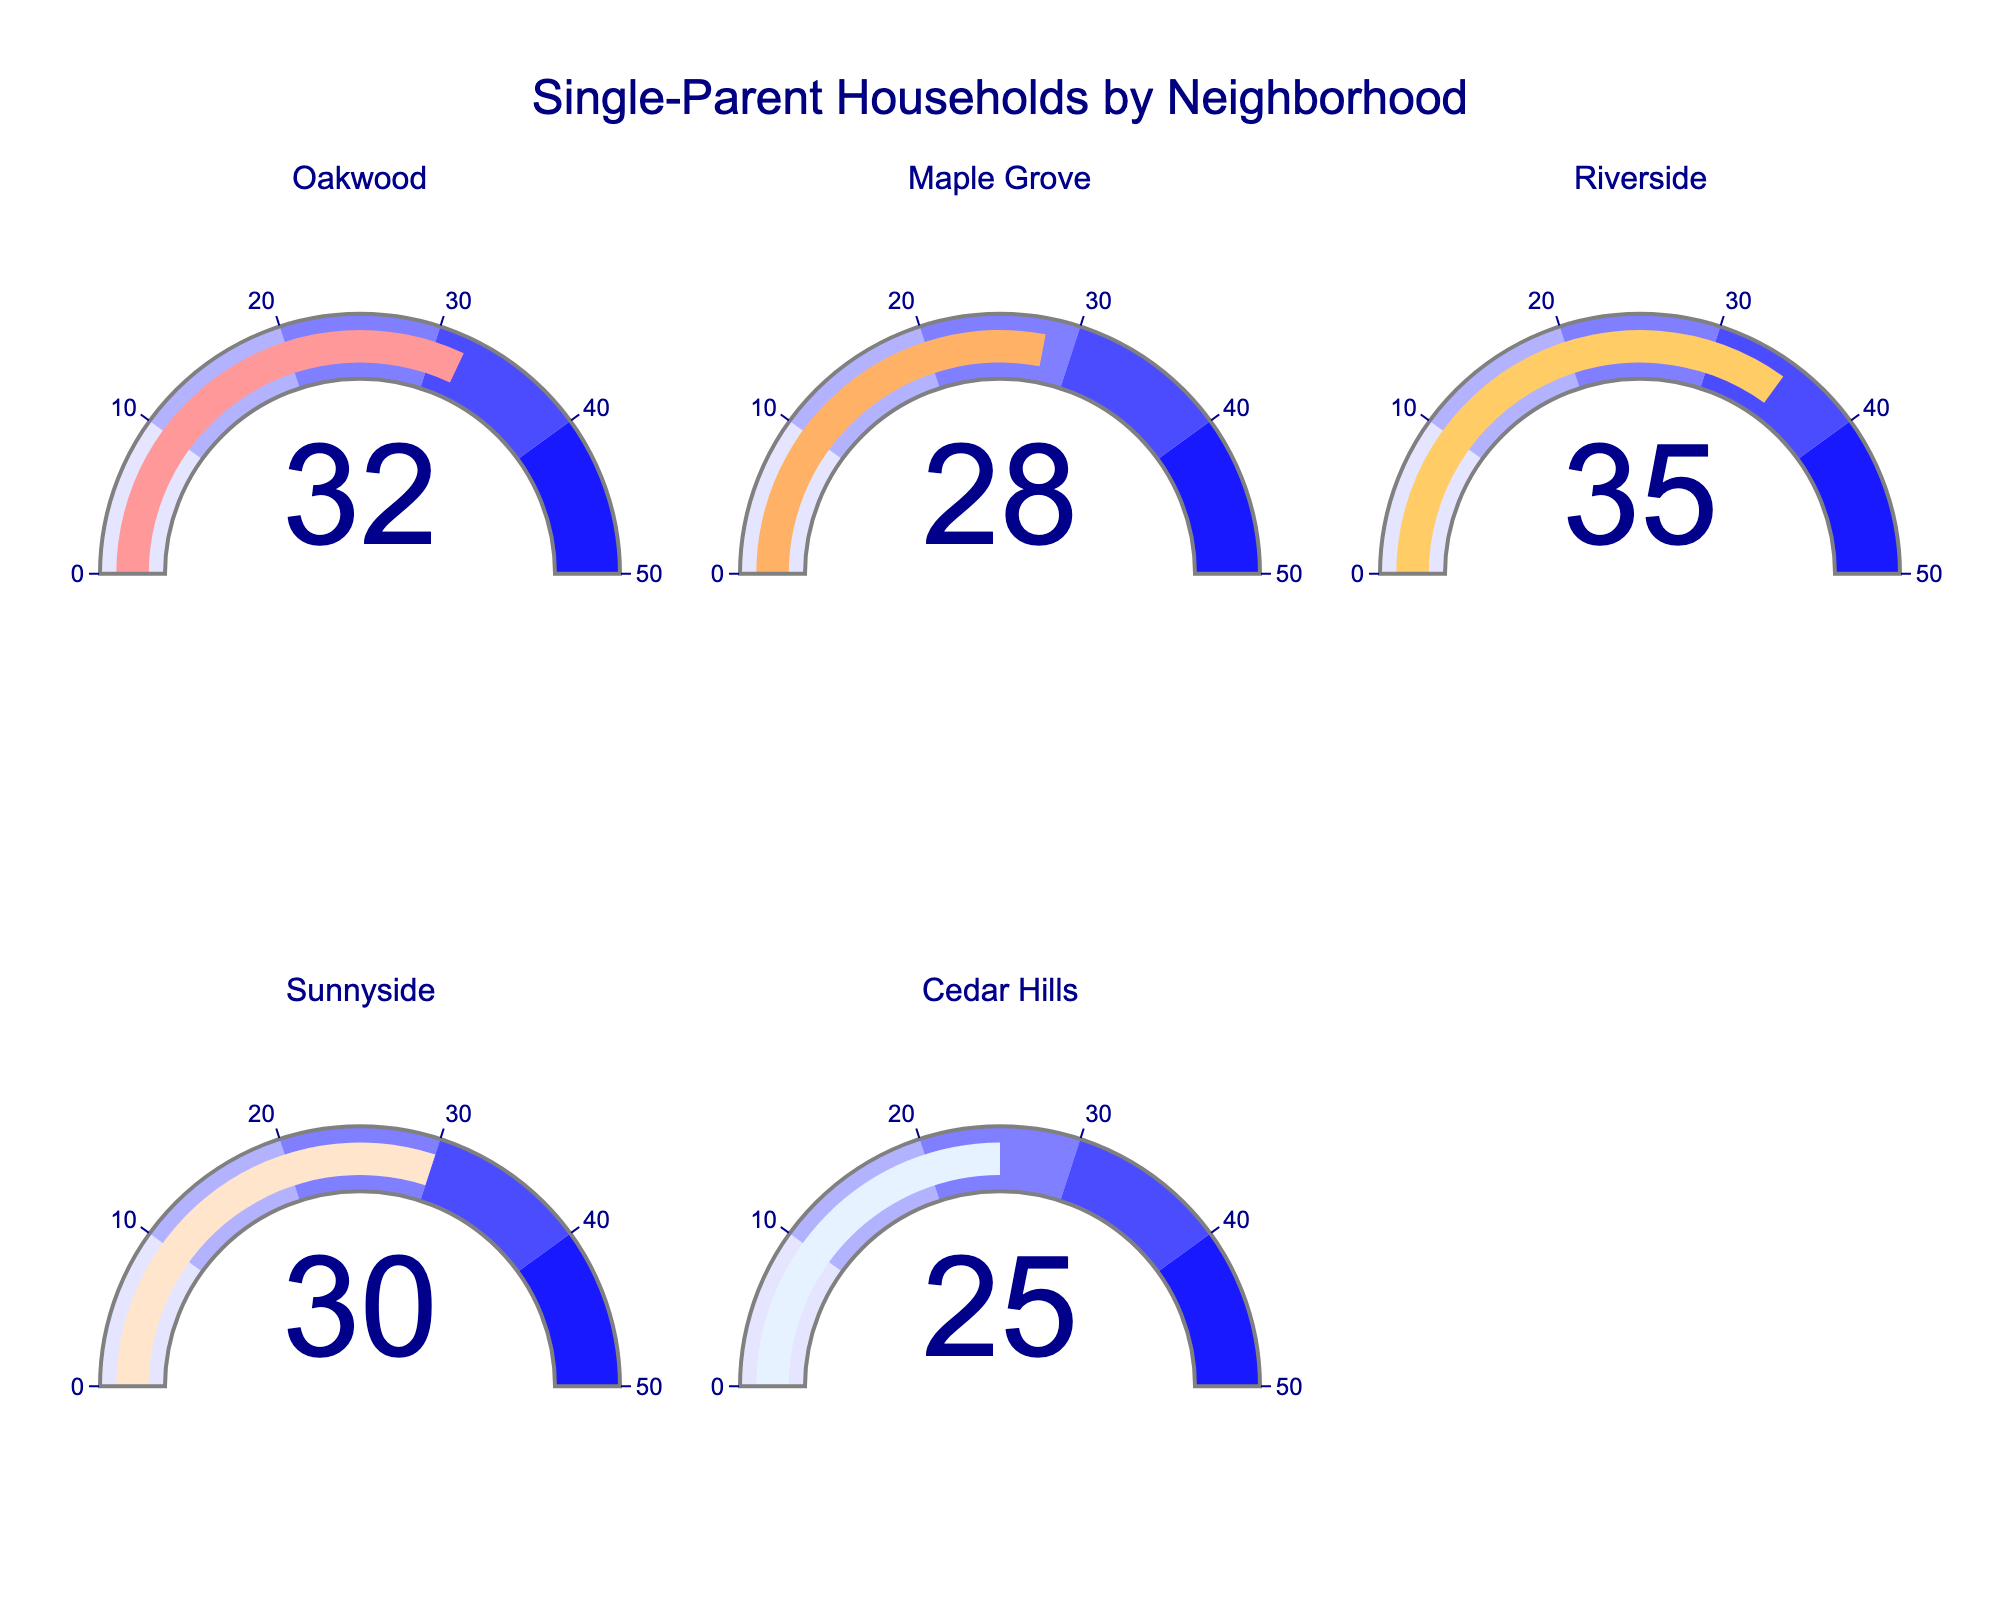What's the highest percentage of single-parent households indicated by the gauge charts? To find the highest percentage, look at all the gauges and identify the highest number displayed. In this case, the Riverside neighborhood has the highest percentage with 35%.
Answer: 35 Which neighborhood has the lowest percentage of single-parent households? Compare the values shown on each gauge. Cedar Hills has the lowest percentage of single-parent households with 25%.
Answer: Cedar Hills What is the average percentage of single-parent households for all the neighborhoods? First, add all the percentages: 32 (Oakwood) + 28 (Maple Grove) + 35 (Riverside) + 30 (Sunnyside) + 25 (Cedar Hills) = 150. Then divide by the number of neighborhoods, which is 5. So, 150 / 5 = 30.
Answer: 30 Are there more neighborhoods with percentages above or below the average? The average percentage is 30. Identify how many neighborhoods are above 30 (Oakwood and Riverside) and how many are below (Maple Grove and Cedar Hills). Sunnyside is equal to 30. Thus, there are 2 neighborhoods above and 2 below the average.
Answer: They are equal Are any two neighborhoods' percentages of single-parent households equal? Review the percentages on the gauge charts and look for duplicates. There are none. Each neighborhood has a unique value.
Answer: No Which neighborhoods have a percentage higher than 30? Compare each neighborhood's percentage to 30. Oakwood (32) and Riverside (35) have percentages higher than 30.
Answer: Oakwood, Riverside 